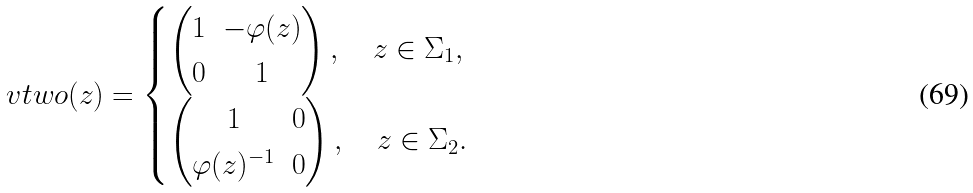<formula> <loc_0><loc_0><loc_500><loc_500>\ v t w o ( z ) = \begin{cases} \begin{pmatrix} 1 & - \varphi ( z ) \\ 0 & 1 \end{pmatrix} , \quad z \in \Sigma _ { 1 } , \\ \begin{pmatrix} 1 & 0 \\ \varphi ( z ) ^ { - 1 } & 0 \end{pmatrix} , \quad z \in \Sigma _ { 2 } . \end{cases}</formula> 